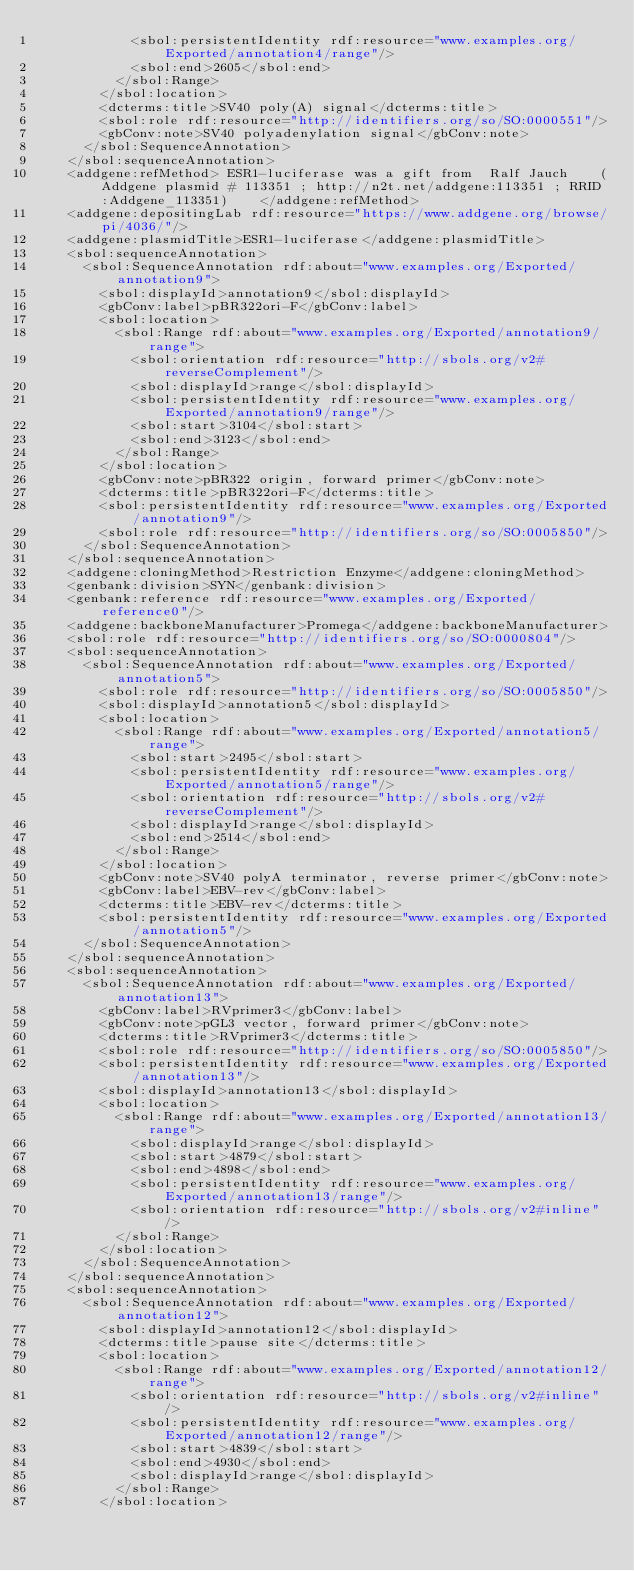Convert code to text. <code><loc_0><loc_0><loc_500><loc_500><_XML_>            <sbol:persistentIdentity rdf:resource="www.examples.org/Exported/annotation4/range"/>
            <sbol:end>2605</sbol:end>
          </sbol:Range>
        </sbol:location>
        <dcterms:title>SV40 poly(A) signal</dcterms:title>
        <sbol:role rdf:resource="http://identifiers.org/so/SO:0000551"/>
        <gbConv:note>SV40 polyadenylation signal</gbConv:note>
      </sbol:SequenceAnnotation>
    </sbol:sequenceAnnotation>
    <addgene:refMethod> ESR1-luciferase was a gift from  Ralf Jauch    (Addgene plasmid # 113351 ; http://n2t.net/addgene:113351 ; RRID:Addgene_113351)    </addgene:refMethod>
    <addgene:depositingLab rdf:resource="https://www.addgene.org/browse/pi/4036/"/>
    <addgene:plasmidTitle>ESR1-luciferase</addgene:plasmidTitle>
    <sbol:sequenceAnnotation>
      <sbol:SequenceAnnotation rdf:about="www.examples.org/Exported/annotation9">
        <sbol:displayId>annotation9</sbol:displayId>
        <gbConv:label>pBR322ori-F</gbConv:label>
        <sbol:location>
          <sbol:Range rdf:about="www.examples.org/Exported/annotation9/range">
            <sbol:orientation rdf:resource="http://sbols.org/v2#reverseComplement"/>
            <sbol:displayId>range</sbol:displayId>
            <sbol:persistentIdentity rdf:resource="www.examples.org/Exported/annotation9/range"/>
            <sbol:start>3104</sbol:start>
            <sbol:end>3123</sbol:end>
          </sbol:Range>
        </sbol:location>
        <gbConv:note>pBR322 origin, forward primer</gbConv:note>
        <dcterms:title>pBR322ori-F</dcterms:title>
        <sbol:persistentIdentity rdf:resource="www.examples.org/Exported/annotation9"/>
        <sbol:role rdf:resource="http://identifiers.org/so/SO:0005850"/>
      </sbol:SequenceAnnotation>
    </sbol:sequenceAnnotation>
    <addgene:cloningMethod>Restriction Enzyme</addgene:cloningMethod>
    <genbank:division>SYN</genbank:division>
    <genbank:reference rdf:resource="www.examples.org/Exported/reference0"/>
    <addgene:backboneManufacturer>Promega</addgene:backboneManufacturer>
    <sbol:role rdf:resource="http://identifiers.org/so/SO:0000804"/>
    <sbol:sequenceAnnotation>
      <sbol:SequenceAnnotation rdf:about="www.examples.org/Exported/annotation5">
        <sbol:role rdf:resource="http://identifiers.org/so/SO:0005850"/>
        <sbol:displayId>annotation5</sbol:displayId>
        <sbol:location>
          <sbol:Range rdf:about="www.examples.org/Exported/annotation5/range">
            <sbol:start>2495</sbol:start>
            <sbol:persistentIdentity rdf:resource="www.examples.org/Exported/annotation5/range"/>
            <sbol:orientation rdf:resource="http://sbols.org/v2#reverseComplement"/>
            <sbol:displayId>range</sbol:displayId>
            <sbol:end>2514</sbol:end>
          </sbol:Range>
        </sbol:location>
        <gbConv:note>SV40 polyA terminator, reverse primer</gbConv:note>
        <gbConv:label>EBV-rev</gbConv:label>
        <dcterms:title>EBV-rev</dcterms:title>
        <sbol:persistentIdentity rdf:resource="www.examples.org/Exported/annotation5"/>
      </sbol:SequenceAnnotation>
    </sbol:sequenceAnnotation>
    <sbol:sequenceAnnotation>
      <sbol:SequenceAnnotation rdf:about="www.examples.org/Exported/annotation13">
        <gbConv:label>RVprimer3</gbConv:label>
        <gbConv:note>pGL3 vector, forward primer</gbConv:note>
        <dcterms:title>RVprimer3</dcterms:title>
        <sbol:role rdf:resource="http://identifiers.org/so/SO:0005850"/>
        <sbol:persistentIdentity rdf:resource="www.examples.org/Exported/annotation13"/>
        <sbol:displayId>annotation13</sbol:displayId>
        <sbol:location>
          <sbol:Range rdf:about="www.examples.org/Exported/annotation13/range">
            <sbol:displayId>range</sbol:displayId>
            <sbol:start>4879</sbol:start>
            <sbol:end>4898</sbol:end>
            <sbol:persistentIdentity rdf:resource="www.examples.org/Exported/annotation13/range"/>
            <sbol:orientation rdf:resource="http://sbols.org/v2#inline"/>
          </sbol:Range>
        </sbol:location>
      </sbol:SequenceAnnotation>
    </sbol:sequenceAnnotation>
    <sbol:sequenceAnnotation>
      <sbol:SequenceAnnotation rdf:about="www.examples.org/Exported/annotation12">
        <sbol:displayId>annotation12</sbol:displayId>
        <dcterms:title>pause site</dcterms:title>
        <sbol:location>
          <sbol:Range rdf:about="www.examples.org/Exported/annotation12/range">
            <sbol:orientation rdf:resource="http://sbols.org/v2#inline"/>
            <sbol:persistentIdentity rdf:resource="www.examples.org/Exported/annotation12/range"/>
            <sbol:start>4839</sbol:start>
            <sbol:end>4930</sbol:end>
            <sbol:displayId>range</sbol:displayId>
          </sbol:Range>
        </sbol:location></code> 